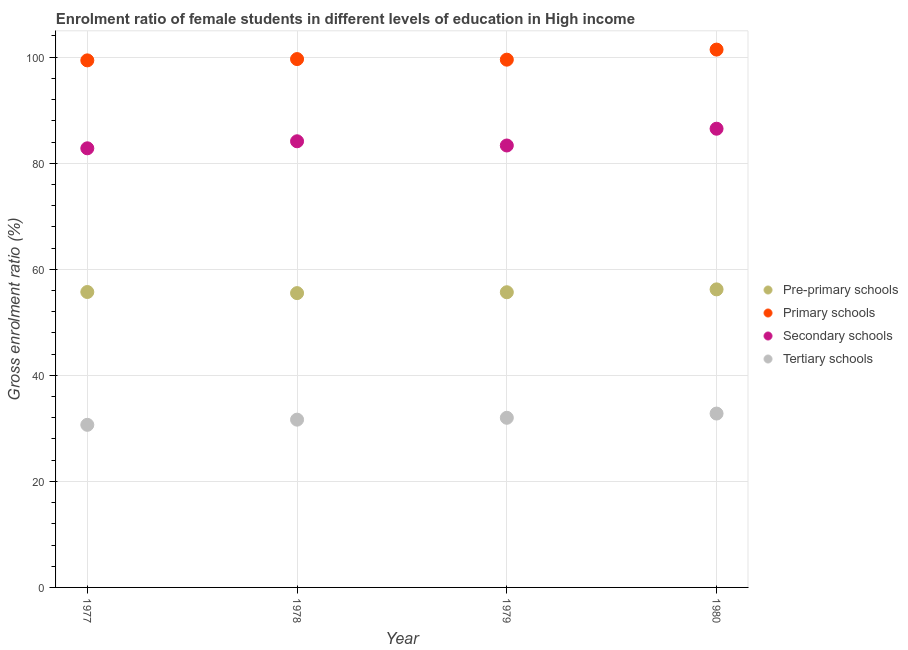What is the gross enrolment ratio(male) in primary schools in 1978?
Your answer should be compact. 99.65. Across all years, what is the maximum gross enrolment ratio(male) in tertiary schools?
Offer a very short reply. 32.79. Across all years, what is the minimum gross enrolment ratio(male) in pre-primary schools?
Your answer should be very brief. 55.51. In which year was the gross enrolment ratio(male) in tertiary schools maximum?
Ensure brevity in your answer.  1980. In which year was the gross enrolment ratio(male) in pre-primary schools minimum?
Offer a very short reply. 1978. What is the total gross enrolment ratio(male) in secondary schools in the graph?
Provide a succinct answer. 336.82. What is the difference between the gross enrolment ratio(male) in secondary schools in 1978 and that in 1979?
Make the answer very short. 0.79. What is the difference between the gross enrolment ratio(male) in primary schools in 1978 and the gross enrolment ratio(male) in pre-primary schools in 1980?
Your answer should be compact. 43.43. What is the average gross enrolment ratio(male) in secondary schools per year?
Provide a succinct answer. 84.21. In the year 1979, what is the difference between the gross enrolment ratio(male) in pre-primary schools and gross enrolment ratio(male) in secondary schools?
Your answer should be compact. -27.68. What is the ratio of the gross enrolment ratio(male) in secondary schools in 1977 to that in 1980?
Provide a short and direct response. 0.96. What is the difference between the highest and the second highest gross enrolment ratio(male) in tertiary schools?
Make the answer very short. 0.8. What is the difference between the highest and the lowest gross enrolment ratio(male) in pre-primary schools?
Keep it short and to the point. 0.71. Is the sum of the gross enrolment ratio(male) in secondary schools in 1978 and 1980 greater than the maximum gross enrolment ratio(male) in tertiary schools across all years?
Keep it short and to the point. Yes. Is it the case that in every year, the sum of the gross enrolment ratio(male) in pre-primary schools and gross enrolment ratio(male) in primary schools is greater than the gross enrolment ratio(male) in secondary schools?
Ensure brevity in your answer.  Yes. Does the gross enrolment ratio(male) in pre-primary schools monotonically increase over the years?
Your answer should be very brief. No. Is the gross enrolment ratio(male) in secondary schools strictly greater than the gross enrolment ratio(male) in tertiary schools over the years?
Offer a terse response. Yes. Is the gross enrolment ratio(male) in tertiary schools strictly less than the gross enrolment ratio(male) in secondary schools over the years?
Your answer should be compact. Yes. What is the difference between two consecutive major ticks on the Y-axis?
Keep it short and to the point. 20. Does the graph contain any zero values?
Your answer should be very brief. No. Where does the legend appear in the graph?
Provide a succinct answer. Center right. How many legend labels are there?
Provide a succinct answer. 4. What is the title of the graph?
Your answer should be compact. Enrolment ratio of female students in different levels of education in High income. What is the label or title of the X-axis?
Give a very brief answer. Year. What is the label or title of the Y-axis?
Give a very brief answer. Gross enrolment ratio (%). What is the Gross enrolment ratio (%) of Pre-primary schools in 1977?
Offer a very short reply. 55.72. What is the Gross enrolment ratio (%) in Primary schools in 1977?
Your response must be concise. 99.4. What is the Gross enrolment ratio (%) in Secondary schools in 1977?
Keep it short and to the point. 82.82. What is the Gross enrolment ratio (%) in Tertiary schools in 1977?
Make the answer very short. 30.67. What is the Gross enrolment ratio (%) in Pre-primary schools in 1978?
Provide a short and direct response. 55.51. What is the Gross enrolment ratio (%) of Primary schools in 1978?
Provide a succinct answer. 99.65. What is the Gross enrolment ratio (%) in Secondary schools in 1978?
Offer a very short reply. 84.14. What is the Gross enrolment ratio (%) of Tertiary schools in 1978?
Ensure brevity in your answer.  31.64. What is the Gross enrolment ratio (%) in Pre-primary schools in 1979?
Ensure brevity in your answer.  55.67. What is the Gross enrolment ratio (%) of Primary schools in 1979?
Make the answer very short. 99.54. What is the Gross enrolment ratio (%) in Secondary schools in 1979?
Keep it short and to the point. 83.35. What is the Gross enrolment ratio (%) in Tertiary schools in 1979?
Your response must be concise. 31.99. What is the Gross enrolment ratio (%) of Pre-primary schools in 1980?
Offer a very short reply. 56.21. What is the Gross enrolment ratio (%) of Primary schools in 1980?
Make the answer very short. 101.44. What is the Gross enrolment ratio (%) in Secondary schools in 1980?
Offer a terse response. 86.51. What is the Gross enrolment ratio (%) in Tertiary schools in 1980?
Offer a terse response. 32.79. Across all years, what is the maximum Gross enrolment ratio (%) in Pre-primary schools?
Offer a very short reply. 56.21. Across all years, what is the maximum Gross enrolment ratio (%) of Primary schools?
Offer a very short reply. 101.44. Across all years, what is the maximum Gross enrolment ratio (%) of Secondary schools?
Give a very brief answer. 86.51. Across all years, what is the maximum Gross enrolment ratio (%) in Tertiary schools?
Your answer should be very brief. 32.79. Across all years, what is the minimum Gross enrolment ratio (%) of Pre-primary schools?
Offer a very short reply. 55.51. Across all years, what is the minimum Gross enrolment ratio (%) of Primary schools?
Your response must be concise. 99.4. Across all years, what is the minimum Gross enrolment ratio (%) of Secondary schools?
Provide a short and direct response. 82.82. Across all years, what is the minimum Gross enrolment ratio (%) in Tertiary schools?
Provide a short and direct response. 30.67. What is the total Gross enrolment ratio (%) of Pre-primary schools in the graph?
Your answer should be very brief. 223.11. What is the total Gross enrolment ratio (%) of Primary schools in the graph?
Ensure brevity in your answer.  400.03. What is the total Gross enrolment ratio (%) of Secondary schools in the graph?
Your answer should be very brief. 336.82. What is the total Gross enrolment ratio (%) of Tertiary schools in the graph?
Keep it short and to the point. 127.1. What is the difference between the Gross enrolment ratio (%) of Pre-primary schools in 1977 and that in 1978?
Ensure brevity in your answer.  0.21. What is the difference between the Gross enrolment ratio (%) in Primary schools in 1977 and that in 1978?
Offer a very short reply. -0.24. What is the difference between the Gross enrolment ratio (%) of Secondary schools in 1977 and that in 1978?
Offer a very short reply. -1.33. What is the difference between the Gross enrolment ratio (%) of Tertiary schools in 1977 and that in 1978?
Provide a succinct answer. -0.98. What is the difference between the Gross enrolment ratio (%) of Pre-primary schools in 1977 and that in 1979?
Offer a very short reply. 0.04. What is the difference between the Gross enrolment ratio (%) in Primary schools in 1977 and that in 1979?
Your answer should be very brief. -0.13. What is the difference between the Gross enrolment ratio (%) in Secondary schools in 1977 and that in 1979?
Provide a succinct answer. -0.53. What is the difference between the Gross enrolment ratio (%) in Tertiary schools in 1977 and that in 1979?
Your response must be concise. -1.33. What is the difference between the Gross enrolment ratio (%) of Pre-primary schools in 1977 and that in 1980?
Ensure brevity in your answer.  -0.5. What is the difference between the Gross enrolment ratio (%) of Primary schools in 1977 and that in 1980?
Offer a very short reply. -2.03. What is the difference between the Gross enrolment ratio (%) of Secondary schools in 1977 and that in 1980?
Keep it short and to the point. -3.7. What is the difference between the Gross enrolment ratio (%) in Tertiary schools in 1977 and that in 1980?
Your response must be concise. -2.13. What is the difference between the Gross enrolment ratio (%) of Pre-primary schools in 1978 and that in 1979?
Give a very brief answer. -0.17. What is the difference between the Gross enrolment ratio (%) in Primary schools in 1978 and that in 1979?
Provide a short and direct response. 0.11. What is the difference between the Gross enrolment ratio (%) of Secondary schools in 1978 and that in 1979?
Your response must be concise. 0.79. What is the difference between the Gross enrolment ratio (%) of Tertiary schools in 1978 and that in 1979?
Make the answer very short. -0.35. What is the difference between the Gross enrolment ratio (%) in Pre-primary schools in 1978 and that in 1980?
Your response must be concise. -0.71. What is the difference between the Gross enrolment ratio (%) of Primary schools in 1978 and that in 1980?
Keep it short and to the point. -1.79. What is the difference between the Gross enrolment ratio (%) in Secondary schools in 1978 and that in 1980?
Provide a short and direct response. -2.37. What is the difference between the Gross enrolment ratio (%) of Tertiary schools in 1978 and that in 1980?
Give a very brief answer. -1.15. What is the difference between the Gross enrolment ratio (%) in Pre-primary schools in 1979 and that in 1980?
Give a very brief answer. -0.54. What is the difference between the Gross enrolment ratio (%) in Primary schools in 1979 and that in 1980?
Provide a short and direct response. -1.9. What is the difference between the Gross enrolment ratio (%) of Secondary schools in 1979 and that in 1980?
Your answer should be compact. -3.16. What is the difference between the Gross enrolment ratio (%) of Tertiary schools in 1979 and that in 1980?
Give a very brief answer. -0.8. What is the difference between the Gross enrolment ratio (%) of Pre-primary schools in 1977 and the Gross enrolment ratio (%) of Primary schools in 1978?
Ensure brevity in your answer.  -43.93. What is the difference between the Gross enrolment ratio (%) in Pre-primary schools in 1977 and the Gross enrolment ratio (%) in Secondary schools in 1978?
Ensure brevity in your answer.  -28.43. What is the difference between the Gross enrolment ratio (%) in Pre-primary schools in 1977 and the Gross enrolment ratio (%) in Tertiary schools in 1978?
Ensure brevity in your answer.  24.07. What is the difference between the Gross enrolment ratio (%) in Primary schools in 1977 and the Gross enrolment ratio (%) in Secondary schools in 1978?
Make the answer very short. 15.26. What is the difference between the Gross enrolment ratio (%) of Primary schools in 1977 and the Gross enrolment ratio (%) of Tertiary schools in 1978?
Ensure brevity in your answer.  67.76. What is the difference between the Gross enrolment ratio (%) in Secondary schools in 1977 and the Gross enrolment ratio (%) in Tertiary schools in 1978?
Make the answer very short. 51.17. What is the difference between the Gross enrolment ratio (%) of Pre-primary schools in 1977 and the Gross enrolment ratio (%) of Primary schools in 1979?
Keep it short and to the point. -43.82. What is the difference between the Gross enrolment ratio (%) of Pre-primary schools in 1977 and the Gross enrolment ratio (%) of Secondary schools in 1979?
Your answer should be compact. -27.63. What is the difference between the Gross enrolment ratio (%) in Pre-primary schools in 1977 and the Gross enrolment ratio (%) in Tertiary schools in 1979?
Your response must be concise. 23.72. What is the difference between the Gross enrolment ratio (%) of Primary schools in 1977 and the Gross enrolment ratio (%) of Secondary schools in 1979?
Your answer should be compact. 16.05. What is the difference between the Gross enrolment ratio (%) in Primary schools in 1977 and the Gross enrolment ratio (%) in Tertiary schools in 1979?
Your answer should be very brief. 67.41. What is the difference between the Gross enrolment ratio (%) of Secondary schools in 1977 and the Gross enrolment ratio (%) of Tertiary schools in 1979?
Make the answer very short. 50.82. What is the difference between the Gross enrolment ratio (%) of Pre-primary schools in 1977 and the Gross enrolment ratio (%) of Primary schools in 1980?
Provide a short and direct response. -45.72. What is the difference between the Gross enrolment ratio (%) of Pre-primary schools in 1977 and the Gross enrolment ratio (%) of Secondary schools in 1980?
Provide a succinct answer. -30.8. What is the difference between the Gross enrolment ratio (%) in Pre-primary schools in 1977 and the Gross enrolment ratio (%) in Tertiary schools in 1980?
Your answer should be very brief. 22.92. What is the difference between the Gross enrolment ratio (%) of Primary schools in 1977 and the Gross enrolment ratio (%) of Secondary schools in 1980?
Keep it short and to the point. 12.89. What is the difference between the Gross enrolment ratio (%) of Primary schools in 1977 and the Gross enrolment ratio (%) of Tertiary schools in 1980?
Make the answer very short. 66.61. What is the difference between the Gross enrolment ratio (%) in Secondary schools in 1977 and the Gross enrolment ratio (%) in Tertiary schools in 1980?
Your answer should be compact. 50.03. What is the difference between the Gross enrolment ratio (%) in Pre-primary schools in 1978 and the Gross enrolment ratio (%) in Primary schools in 1979?
Give a very brief answer. -44.03. What is the difference between the Gross enrolment ratio (%) in Pre-primary schools in 1978 and the Gross enrolment ratio (%) in Secondary schools in 1979?
Your answer should be very brief. -27.84. What is the difference between the Gross enrolment ratio (%) in Pre-primary schools in 1978 and the Gross enrolment ratio (%) in Tertiary schools in 1979?
Your response must be concise. 23.51. What is the difference between the Gross enrolment ratio (%) in Primary schools in 1978 and the Gross enrolment ratio (%) in Secondary schools in 1979?
Make the answer very short. 16.3. What is the difference between the Gross enrolment ratio (%) of Primary schools in 1978 and the Gross enrolment ratio (%) of Tertiary schools in 1979?
Keep it short and to the point. 67.65. What is the difference between the Gross enrolment ratio (%) in Secondary schools in 1978 and the Gross enrolment ratio (%) in Tertiary schools in 1979?
Offer a very short reply. 52.15. What is the difference between the Gross enrolment ratio (%) of Pre-primary schools in 1978 and the Gross enrolment ratio (%) of Primary schools in 1980?
Offer a very short reply. -45.93. What is the difference between the Gross enrolment ratio (%) in Pre-primary schools in 1978 and the Gross enrolment ratio (%) in Secondary schools in 1980?
Offer a very short reply. -31.01. What is the difference between the Gross enrolment ratio (%) in Pre-primary schools in 1978 and the Gross enrolment ratio (%) in Tertiary schools in 1980?
Keep it short and to the point. 22.71. What is the difference between the Gross enrolment ratio (%) of Primary schools in 1978 and the Gross enrolment ratio (%) of Secondary schools in 1980?
Give a very brief answer. 13.13. What is the difference between the Gross enrolment ratio (%) in Primary schools in 1978 and the Gross enrolment ratio (%) in Tertiary schools in 1980?
Provide a short and direct response. 66.86. What is the difference between the Gross enrolment ratio (%) of Secondary schools in 1978 and the Gross enrolment ratio (%) of Tertiary schools in 1980?
Provide a succinct answer. 51.35. What is the difference between the Gross enrolment ratio (%) of Pre-primary schools in 1979 and the Gross enrolment ratio (%) of Primary schools in 1980?
Your response must be concise. -45.76. What is the difference between the Gross enrolment ratio (%) in Pre-primary schools in 1979 and the Gross enrolment ratio (%) in Secondary schools in 1980?
Keep it short and to the point. -30.84. What is the difference between the Gross enrolment ratio (%) in Pre-primary schools in 1979 and the Gross enrolment ratio (%) in Tertiary schools in 1980?
Your response must be concise. 22.88. What is the difference between the Gross enrolment ratio (%) in Primary schools in 1979 and the Gross enrolment ratio (%) in Secondary schools in 1980?
Make the answer very short. 13.02. What is the difference between the Gross enrolment ratio (%) in Primary schools in 1979 and the Gross enrolment ratio (%) in Tertiary schools in 1980?
Your answer should be compact. 66.75. What is the difference between the Gross enrolment ratio (%) in Secondary schools in 1979 and the Gross enrolment ratio (%) in Tertiary schools in 1980?
Give a very brief answer. 50.56. What is the average Gross enrolment ratio (%) in Pre-primary schools per year?
Offer a very short reply. 55.78. What is the average Gross enrolment ratio (%) in Primary schools per year?
Make the answer very short. 100.01. What is the average Gross enrolment ratio (%) in Secondary schools per year?
Provide a short and direct response. 84.21. What is the average Gross enrolment ratio (%) in Tertiary schools per year?
Make the answer very short. 31.77. In the year 1977, what is the difference between the Gross enrolment ratio (%) of Pre-primary schools and Gross enrolment ratio (%) of Primary schools?
Your answer should be very brief. -43.69. In the year 1977, what is the difference between the Gross enrolment ratio (%) of Pre-primary schools and Gross enrolment ratio (%) of Secondary schools?
Ensure brevity in your answer.  -27.1. In the year 1977, what is the difference between the Gross enrolment ratio (%) in Pre-primary schools and Gross enrolment ratio (%) in Tertiary schools?
Provide a short and direct response. 25.05. In the year 1977, what is the difference between the Gross enrolment ratio (%) in Primary schools and Gross enrolment ratio (%) in Secondary schools?
Provide a short and direct response. 16.59. In the year 1977, what is the difference between the Gross enrolment ratio (%) in Primary schools and Gross enrolment ratio (%) in Tertiary schools?
Your answer should be compact. 68.74. In the year 1977, what is the difference between the Gross enrolment ratio (%) of Secondary schools and Gross enrolment ratio (%) of Tertiary schools?
Ensure brevity in your answer.  52.15. In the year 1978, what is the difference between the Gross enrolment ratio (%) in Pre-primary schools and Gross enrolment ratio (%) in Primary schools?
Your answer should be very brief. -44.14. In the year 1978, what is the difference between the Gross enrolment ratio (%) in Pre-primary schools and Gross enrolment ratio (%) in Secondary schools?
Offer a terse response. -28.64. In the year 1978, what is the difference between the Gross enrolment ratio (%) in Pre-primary schools and Gross enrolment ratio (%) in Tertiary schools?
Provide a short and direct response. 23.86. In the year 1978, what is the difference between the Gross enrolment ratio (%) of Primary schools and Gross enrolment ratio (%) of Secondary schools?
Ensure brevity in your answer.  15.5. In the year 1978, what is the difference between the Gross enrolment ratio (%) of Primary schools and Gross enrolment ratio (%) of Tertiary schools?
Offer a terse response. 68. In the year 1978, what is the difference between the Gross enrolment ratio (%) of Secondary schools and Gross enrolment ratio (%) of Tertiary schools?
Provide a short and direct response. 52.5. In the year 1979, what is the difference between the Gross enrolment ratio (%) of Pre-primary schools and Gross enrolment ratio (%) of Primary schools?
Make the answer very short. -43.86. In the year 1979, what is the difference between the Gross enrolment ratio (%) of Pre-primary schools and Gross enrolment ratio (%) of Secondary schools?
Your response must be concise. -27.68. In the year 1979, what is the difference between the Gross enrolment ratio (%) in Pre-primary schools and Gross enrolment ratio (%) in Tertiary schools?
Your answer should be compact. 23.68. In the year 1979, what is the difference between the Gross enrolment ratio (%) of Primary schools and Gross enrolment ratio (%) of Secondary schools?
Give a very brief answer. 16.19. In the year 1979, what is the difference between the Gross enrolment ratio (%) of Primary schools and Gross enrolment ratio (%) of Tertiary schools?
Your response must be concise. 67.54. In the year 1979, what is the difference between the Gross enrolment ratio (%) in Secondary schools and Gross enrolment ratio (%) in Tertiary schools?
Keep it short and to the point. 51.36. In the year 1980, what is the difference between the Gross enrolment ratio (%) of Pre-primary schools and Gross enrolment ratio (%) of Primary schools?
Offer a terse response. -45.22. In the year 1980, what is the difference between the Gross enrolment ratio (%) of Pre-primary schools and Gross enrolment ratio (%) of Secondary schools?
Your response must be concise. -30.3. In the year 1980, what is the difference between the Gross enrolment ratio (%) of Pre-primary schools and Gross enrolment ratio (%) of Tertiary schools?
Provide a succinct answer. 23.42. In the year 1980, what is the difference between the Gross enrolment ratio (%) of Primary schools and Gross enrolment ratio (%) of Secondary schools?
Offer a terse response. 14.92. In the year 1980, what is the difference between the Gross enrolment ratio (%) in Primary schools and Gross enrolment ratio (%) in Tertiary schools?
Make the answer very short. 68.65. In the year 1980, what is the difference between the Gross enrolment ratio (%) in Secondary schools and Gross enrolment ratio (%) in Tertiary schools?
Ensure brevity in your answer.  53.72. What is the ratio of the Gross enrolment ratio (%) in Secondary schools in 1977 to that in 1978?
Your answer should be compact. 0.98. What is the ratio of the Gross enrolment ratio (%) in Tertiary schools in 1977 to that in 1978?
Keep it short and to the point. 0.97. What is the ratio of the Gross enrolment ratio (%) in Primary schools in 1977 to that in 1979?
Your response must be concise. 1. What is the ratio of the Gross enrolment ratio (%) in Tertiary schools in 1977 to that in 1979?
Your answer should be compact. 0.96. What is the ratio of the Gross enrolment ratio (%) in Pre-primary schools in 1977 to that in 1980?
Provide a succinct answer. 0.99. What is the ratio of the Gross enrolment ratio (%) in Primary schools in 1977 to that in 1980?
Your response must be concise. 0.98. What is the ratio of the Gross enrolment ratio (%) in Secondary schools in 1977 to that in 1980?
Provide a short and direct response. 0.96. What is the ratio of the Gross enrolment ratio (%) in Tertiary schools in 1977 to that in 1980?
Provide a short and direct response. 0.94. What is the ratio of the Gross enrolment ratio (%) in Pre-primary schools in 1978 to that in 1979?
Offer a terse response. 1. What is the ratio of the Gross enrolment ratio (%) in Primary schools in 1978 to that in 1979?
Your answer should be compact. 1. What is the ratio of the Gross enrolment ratio (%) of Secondary schools in 1978 to that in 1979?
Your answer should be very brief. 1.01. What is the ratio of the Gross enrolment ratio (%) in Pre-primary schools in 1978 to that in 1980?
Ensure brevity in your answer.  0.99. What is the ratio of the Gross enrolment ratio (%) of Primary schools in 1978 to that in 1980?
Keep it short and to the point. 0.98. What is the ratio of the Gross enrolment ratio (%) in Secondary schools in 1978 to that in 1980?
Your response must be concise. 0.97. What is the ratio of the Gross enrolment ratio (%) of Tertiary schools in 1978 to that in 1980?
Offer a very short reply. 0.96. What is the ratio of the Gross enrolment ratio (%) in Pre-primary schools in 1979 to that in 1980?
Keep it short and to the point. 0.99. What is the ratio of the Gross enrolment ratio (%) in Primary schools in 1979 to that in 1980?
Give a very brief answer. 0.98. What is the ratio of the Gross enrolment ratio (%) in Secondary schools in 1979 to that in 1980?
Your answer should be compact. 0.96. What is the ratio of the Gross enrolment ratio (%) in Tertiary schools in 1979 to that in 1980?
Ensure brevity in your answer.  0.98. What is the difference between the highest and the second highest Gross enrolment ratio (%) in Pre-primary schools?
Your response must be concise. 0.5. What is the difference between the highest and the second highest Gross enrolment ratio (%) of Primary schools?
Keep it short and to the point. 1.79. What is the difference between the highest and the second highest Gross enrolment ratio (%) in Secondary schools?
Your answer should be very brief. 2.37. What is the difference between the highest and the second highest Gross enrolment ratio (%) of Tertiary schools?
Your answer should be compact. 0.8. What is the difference between the highest and the lowest Gross enrolment ratio (%) in Pre-primary schools?
Provide a succinct answer. 0.71. What is the difference between the highest and the lowest Gross enrolment ratio (%) of Primary schools?
Keep it short and to the point. 2.03. What is the difference between the highest and the lowest Gross enrolment ratio (%) in Secondary schools?
Give a very brief answer. 3.7. What is the difference between the highest and the lowest Gross enrolment ratio (%) of Tertiary schools?
Give a very brief answer. 2.13. 